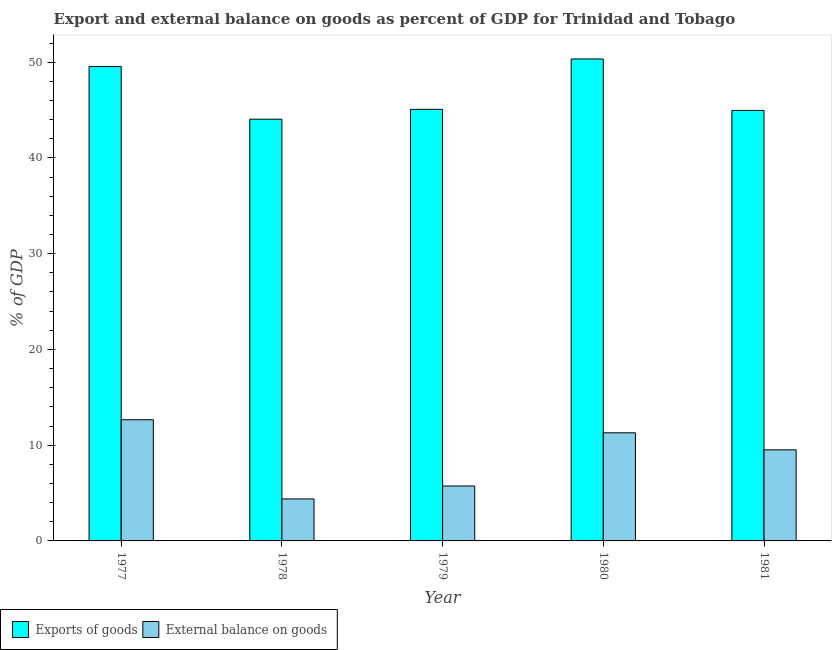How many different coloured bars are there?
Provide a succinct answer. 2. Are the number of bars per tick equal to the number of legend labels?
Your response must be concise. Yes. How many bars are there on the 1st tick from the left?
Your response must be concise. 2. How many bars are there on the 4th tick from the right?
Your answer should be compact. 2. What is the label of the 4th group of bars from the left?
Your answer should be compact. 1980. What is the external balance on goods as percentage of gdp in 1979?
Make the answer very short. 5.74. Across all years, what is the maximum external balance on goods as percentage of gdp?
Your response must be concise. 12.66. Across all years, what is the minimum export of goods as percentage of gdp?
Provide a short and direct response. 44.05. In which year was the external balance on goods as percentage of gdp maximum?
Your response must be concise. 1977. In which year was the export of goods as percentage of gdp minimum?
Ensure brevity in your answer.  1978. What is the total external balance on goods as percentage of gdp in the graph?
Give a very brief answer. 43.58. What is the difference between the export of goods as percentage of gdp in 1978 and that in 1980?
Keep it short and to the point. -6.29. What is the difference between the export of goods as percentage of gdp in 1977 and the external balance on goods as percentage of gdp in 1979?
Offer a terse response. 4.48. What is the average external balance on goods as percentage of gdp per year?
Your answer should be very brief. 8.72. In how many years, is the export of goods as percentage of gdp greater than 8 %?
Your answer should be compact. 5. What is the ratio of the external balance on goods as percentage of gdp in 1980 to that in 1981?
Give a very brief answer. 1.19. Is the export of goods as percentage of gdp in 1977 less than that in 1981?
Provide a succinct answer. No. What is the difference between the highest and the second highest export of goods as percentage of gdp?
Provide a succinct answer. 0.78. What is the difference between the highest and the lowest export of goods as percentage of gdp?
Keep it short and to the point. 6.29. Is the sum of the export of goods as percentage of gdp in 1978 and 1981 greater than the maximum external balance on goods as percentage of gdp across all years?
Offer a very short reply. Yes. What does the 1st bar from the left in 1980 represents?
Keep it short and to the point. Exports of goods. What does the 1st bar from the right in 1979 represents?
Your response must be concise. External balance on goods. How many bars are there?
Give a very brief answer. 10. How many years are there in the graph?
Give a very brief answer. 5. Are the values on the major ticks of Y-axis written in scientific E-notation?
Provide a short and direct response. No. Does the graph contain any zero values?
Provide a short and direct response. No. Does the graph contain grids?
Provide a short and direct response. No. Where does the legend appear in the graph?
Make the answer very short. Bottom left. What is the title of the graph?
Offer a terse response. Export and external balance on goods as percent of GDP for Trinidad and Tobago. Does "Investment" appear as one of the legend labels in the graph?
Your answer should be very brief. No. What is the label or title of the Y-axis?
Your response must be concise. % of GDP. What is the % of GDP of Exports of goods in 1977?
Offer a very short reply. 49.55. What is the % of GDP in External balance on goods in 1977?
Provide a succinct answer. 12.66. What is the % of GDP of Exports of goods in 1978?
Provide a succinct answer. 44.05. What is the % of GDP in External balance on goods in 1978?
Offer a very short reply. 4.39. What is the % of GDP of Exports of goods in 1979?
Your response must be concise. 45.07. What is the % of GDP of External balance on goods in 1979?
Offer a very short reply. 5.74. What is the % of GDP of Exports of goods in 1980?
Make the answer very short. 50.33. What is the % of GDP in External balance on goods in 1980?
Offer a very short reply. 11.29. What is the % of GDP of Exports of goods in 1981?
Keep it short and to the point. 44.96. What is the % of GDP in External balance on goods in 1981?
Make the answer very short. 9.51. Across all years, what is the maximum % of GDP in Exports of goods?
Your answer should be compact. 50.33. Across all years, what is the maximum % of GDP of External balance on goods?
Your answer should be very brief. 12.66. Across all years, what is the minimum % of GDP in Exports of goods?
Your answer should be compact. 44.05. Across all years, what is the minimum % of GDP of External balance on goods?
Make the answer very short. 4.39. What is the total % of GDP in Exports of goods in the graph?
Provide a short and direct response. 233.97. What is the total % of GDP in External balance on goods in the graph?
Provide a short and direct response. 43.58. What is the difference between the % of GDP of Exports of goods in 1977 and that in 1978?
Your answer should be compact. 5.5. What is the difference between the % of GDP of External balance on goods in 1977 and that in 1978?
Provide a short and direct response. 8.27. What is the difference between the % of GDP of Exports of goods in 1977 and that in 1979?
Your response must be concise. 4.48. What is the difference between the % of GDP in External balance on goods in 1977 and that in 1979?
Provide a short and direct response. 6.92. What is the difference between the % of GDP in Exports of goods in 1977 and that in 1980?
Provide a short and direct response. -0.78. What is the difference between the % of GDP in External balance on goods in 1977 and that in 1980?
Your answer should be very brief. 1.36. What is the difference between the % of GDP in Exports of goods in 1977 and that in 1981?
Keep it short and to the point. 4.59. What is the difference between the % of GDP of External balance on goods in 1977 and that in 1981?
Make the answer very short. 3.14. What is the difference between the % of GDP of Exports of goods in 1978 and that in 1979?
Give a very brief answer. -1.03. What is the difference between the % of GDP of External balance on goods in 1978 and that in 1979?
Your response must be concise. -1.35. What is the difference between the % of GDP of Exports of goods in 1978 and that in 1980?
Your answer should be compact. -6.29. What is the difference between the % of GDP of External balance on goods in 1978 and that in 1980?
Offer a very short reply. -6.9. What is the difference between the % of GDP of Exports of goods in 1978 and that in 1981?
Make the answer very short. -0.92. What is the difference between the % of GDP of External balance on goods in 1978 and that in 1981?
Provide a short and direct response. -5.12. What is the difference between the % of GDP in Exports of goods in 1979 and that in 1980?
Your response must be concise. -5.26. What is the difference between the % of GDP in External balance on goods in 1979 and that in 1980?
Provide a short and direct response. -5.56. What is the difference between the % of GDP of Exports of goods in 1979 and that in 1981?
Your answer should be very brief. 0.11. What is the difference between the % of GDP of External balance on goods in 1979 and that in 1981?
Keep it short and to the point. -3.77. What is the difference between the % of GDP in Exports of goods in 1980 and that in 1981?
Offer a terse response. 5.37. What is the difference between the % of GDP of External balance on goods in 1980 and that in 1981?
Your response must be concise. 1.78. What is the difference between the % of GDP in Exports of goods in 1977 and the % of GDP in External balance on goods in 1978?
Offer a terse response. 45.16. What is the difference between the % of GDP in Exports of goods in 1977 and the % of GDP in External balance on goods in 1979?
Keep it short and to the point. 43.82. What is the difference between the % of GDP of Exports of goods in 1977 and the % of GDP of External balance on goods in 1980?
Give a very brief answer. 38.26. What is the difference between the % of GDP of Exports of goods in 1977 and the % of GDP of External balance on goods in 1981?
Give a very brief answer. 40.04. What is the difference between the % of GDP of Exports of goods in 1978 and the % of GDP of External balance on goods in 1979?
Your answer should be very brief. 38.31. What is the difference between the % of GDP of Exports of goods in 1978 and the % of GDP of External balance on goods in 1980?
Your answer should be very brief. 32.75. What is the difference between the % of GDP of Exports of goods in 1978 and the % of GDP of External balance on goods in 1981?
Your response must be concise. 34.54. What is the difference between the % of GDP in Exports of goods in 1979 and the % of GDP in External balance on goods in 1980?
Your answer should be very brief. 33.78. What is the difference between the % of GDP in Exports of goods in 1979 and the % of GDP in External balance on goods in 1981?
Your answer should be compact. 35.56. What is the difference between the % of GDP of Exports of goods in 1980 and the % of GDP of External balance on goods in 1981?
Offer a very short reply. 40.82. What is the average % of GDP in Exports of goods per year?
Offer a very short reply. 46.79. What is the average % of GDP of External balance on goods per year?
Your answer should be very brief. 8.72. In the year 1977, what is the difference between the % of GDP of Exports of goods and % of GDP of External balance on goods?
Make the answer very short. 36.9. In the year 1978, what is the difference between the % of GDP of Exports of goods and % of GDP of External balance on goods?
Offer a terse response. 39.66. In the year 1979, what is the difference between the % of GDP of Exports of goods and % of GDP of External balance on goods?
Make the answer very short. 39.34. In the year 1980, what is the difference between the % of GDP in Exports of goods and % of GDP in External balance on goods?
Your answer should be compact. 39.04. In the year 1981, what is the difference between the % of GDP in Exports of goods and % of GDP in External balance on goods?
Provide a succinct answer. 35.45. What is the ratio of the % of GDP in Exports of goods in 1977 to that in 1978?
Offer a very short reply. 1.12. What is the ratio of the % of GDP of External balance on goods in 1977 to that in 1978?
Your answer should be compact. 2.88. What is the ratio of the % of GDP in Exports of goods in 1977 to that in 1979?
Provide a short and direct response. 1.1. What is the ratio of the % of GDP in External balance on goods in 1977 to that in 1979?
Your answer should be compact. 2.21. What is the ratio of the % of GDP of Exports of goods in 1977 to that in 1980?
Make the answer very short. 0.98. What is the ratio of the % of GDP of External balance on goods in 1977 to that in 1980?
Provide a short and direct response. 1.12. What is the ratio of the % of GDP of Exports of goods in 1977 to that in 1981?
Make the answer very short. 1.1. What is the ratio of the % of GDP of External balance on goods in 1977 to that in 1981?
Your response must be concise. 1.33. What is the ratio of the % of GDP in Exports of goods in 1978 to that in 1979?
Make the answer very short. 0.98. What is the ratio of the % of GDP in External balance on goods in 1978 to that in 1979?
Provide a short and direct response. 0.76. What is the ratio of the % of GDP in Exports of goods in 1978 to that in 1980?
Offer a very short reply. 0.88. What is the ratio of the % of GDP of External balance on goods in 1978 to that in 1980?
Offer a terse response. 0.39. What is the ratio of the % of GDP of Exports of goods in 1978 to that in 1981?
Your answer should be compact. 0.98. What is the ratio of the % of GDP in External balance on goods in 1978 to that in 1981?
Your answer should be very brief. 0.46. What is the ratio of the % of GDP in Exports of goods in 1979 to that in 1980?
Make the answer very short. 0.9. What is the ratio of the % of GDP of External balance on goods in 1979 to that in 1980?
Offer a terse response. 0.51. What is the ratio of the % of GDP in Exports of goods in 1979 to that in 1981?
Give a very brief answer. 1. What is the ratio of the % of GDP in External balance on goods in 1979 to that in 1981?
Provide a succinct answer. 0.6. What is the ratio of the % of GDP of Exports of goods in 1980 to that in 1981?
Provide a succinct answer. 1.12. What is the ratio of the % of GDP in External balance on goods in 1980 to that in 1981?
Your answer should be very brief. 1.19. What is the difference between the highest and the second highest % of GDP of Exports of goods?
Keep it short and to the point. 0.78. What is the difference between the highest and the second highest % of GDP of External balance on goods?
Ensure brevity in your answer.  1.36. What is the difference between the highest and the lowest % of GDP in Exports of goods?
Your answer should be very brief. 6.29. What is the difference between the highest and the lowest % of GDP of External balance on goods?
Keep it short and to the point. 8.27. 